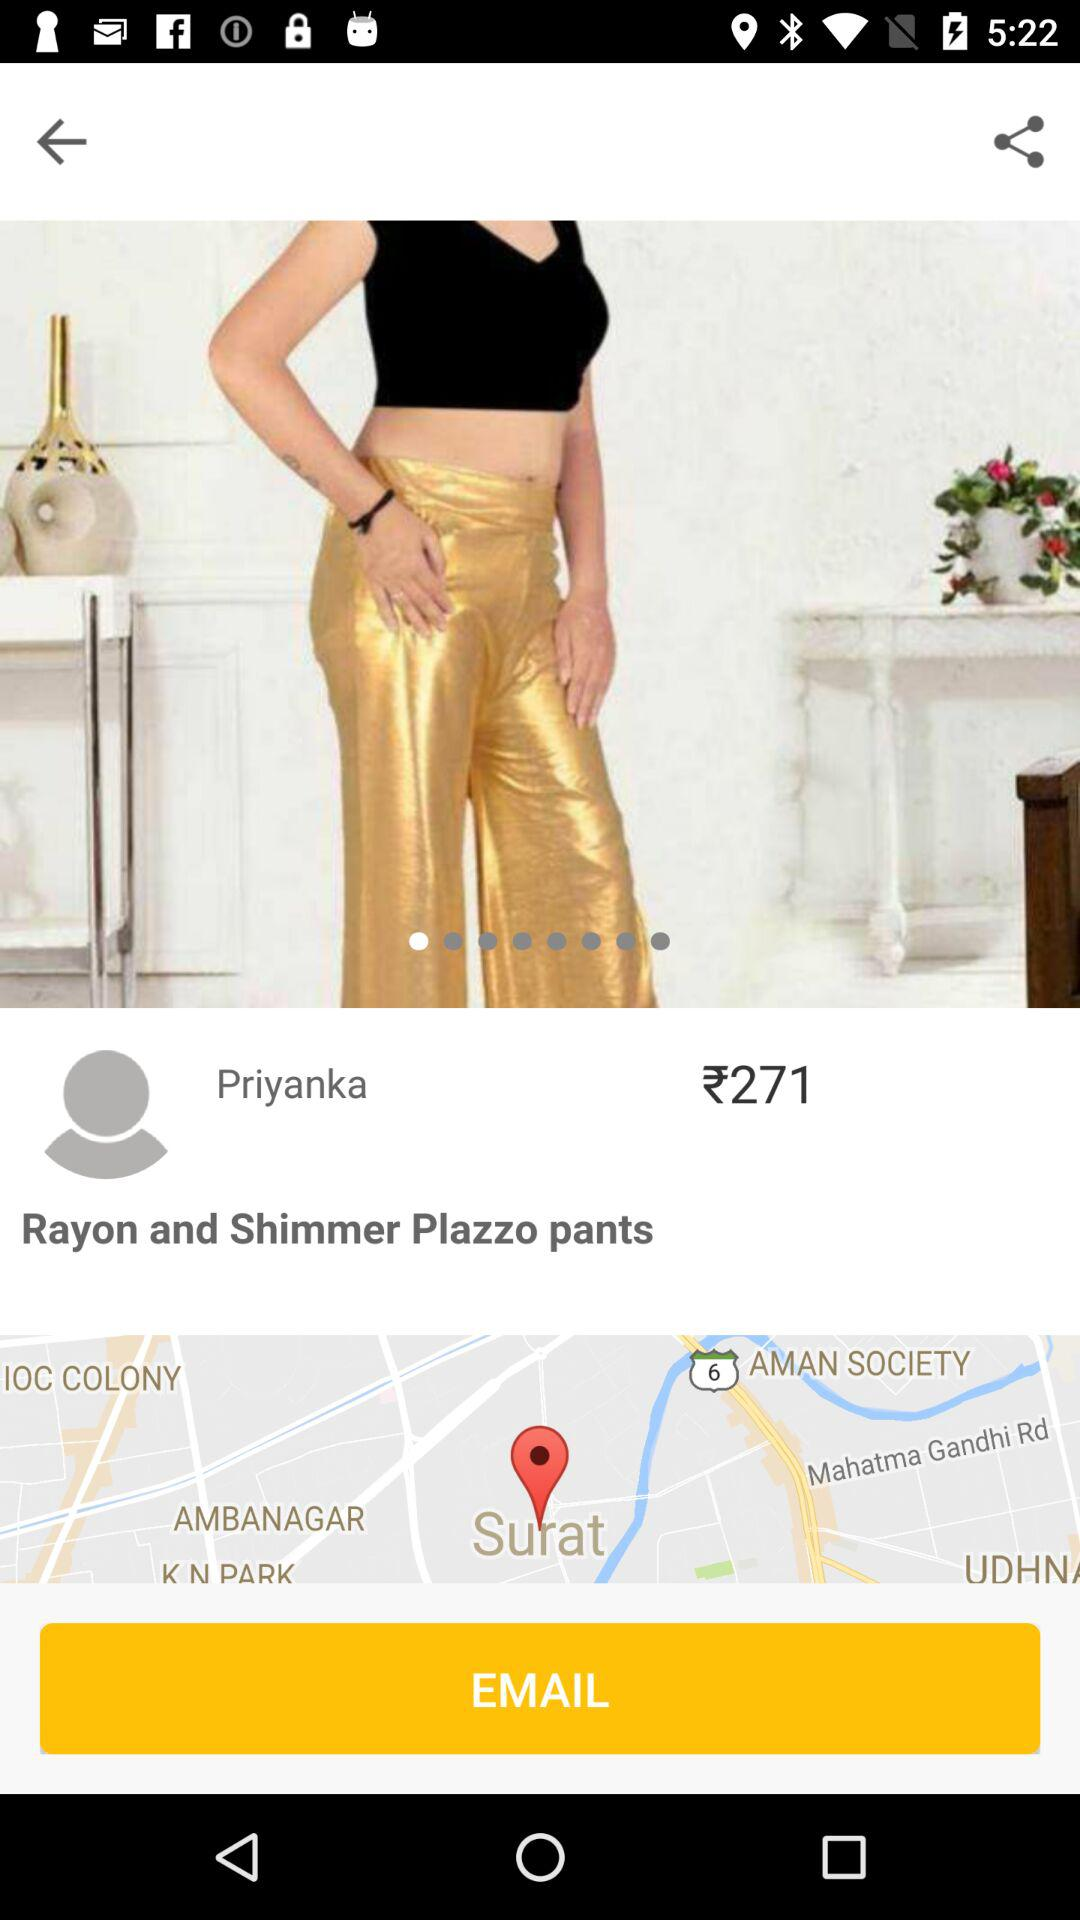What is the price of "Plazzo pants"? The price of "Plazzo pants" is ₹271. 